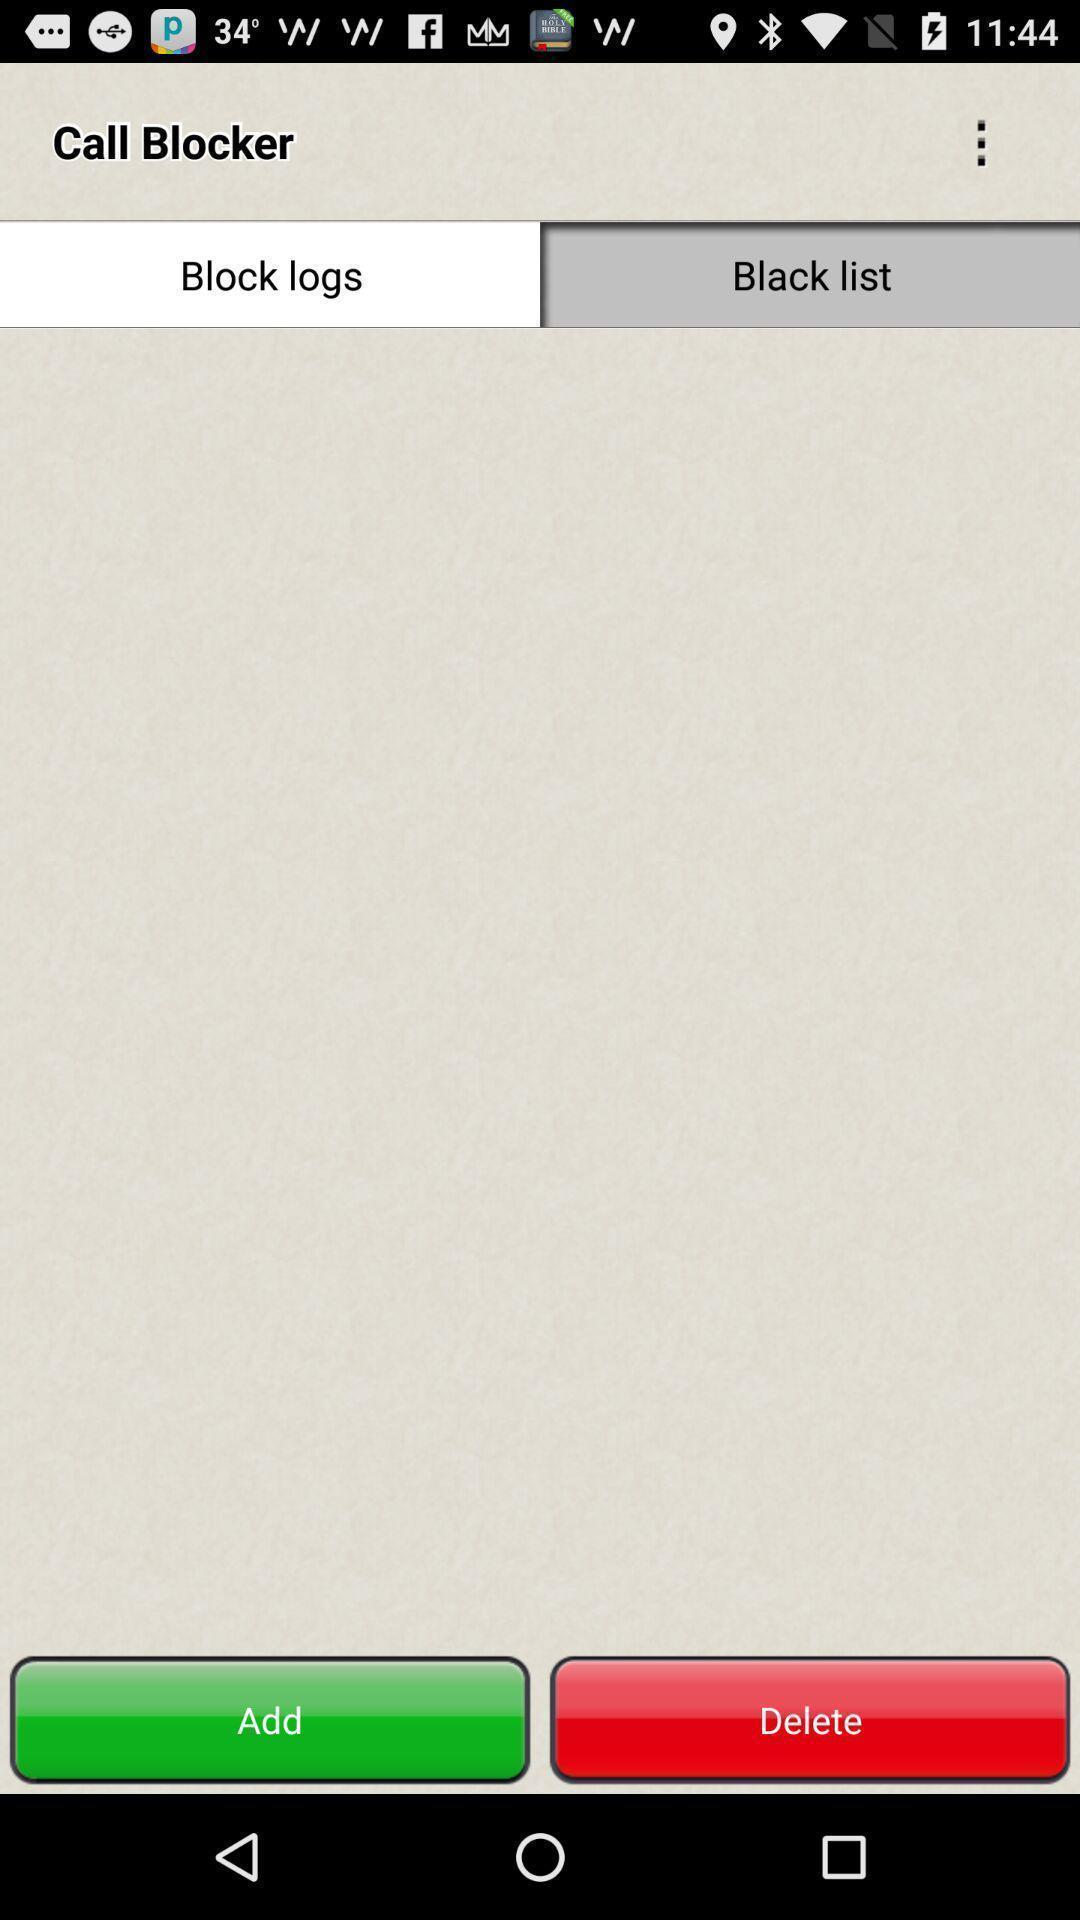What is the overall content of this screenshot? Screen displaying multiple options in a phone blocking application. 